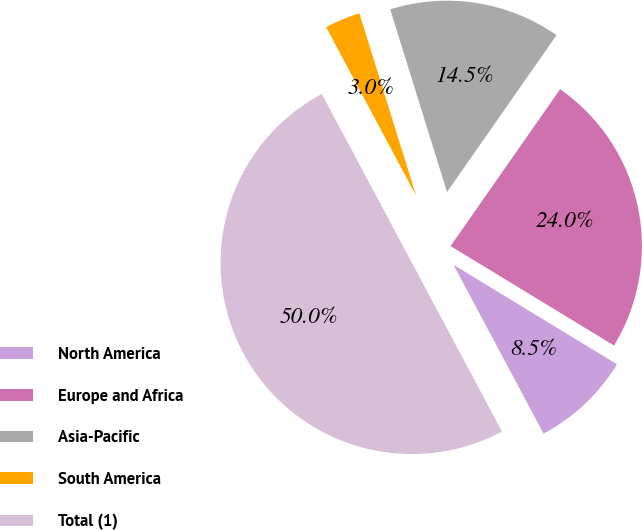Convert chart. <chart><loc_0><loc_0><loc_500><loc_500><pie_chart><fcel>North America<fcel>Europe and Africa<fcel>Asia-Pacific<fcel>South America<fcel>Total (1)<nl><fcel>8.5%<fcel>24.0%<fcel>14.5%<fcel>3.0%<fcel>50.0%<nl></chart> 